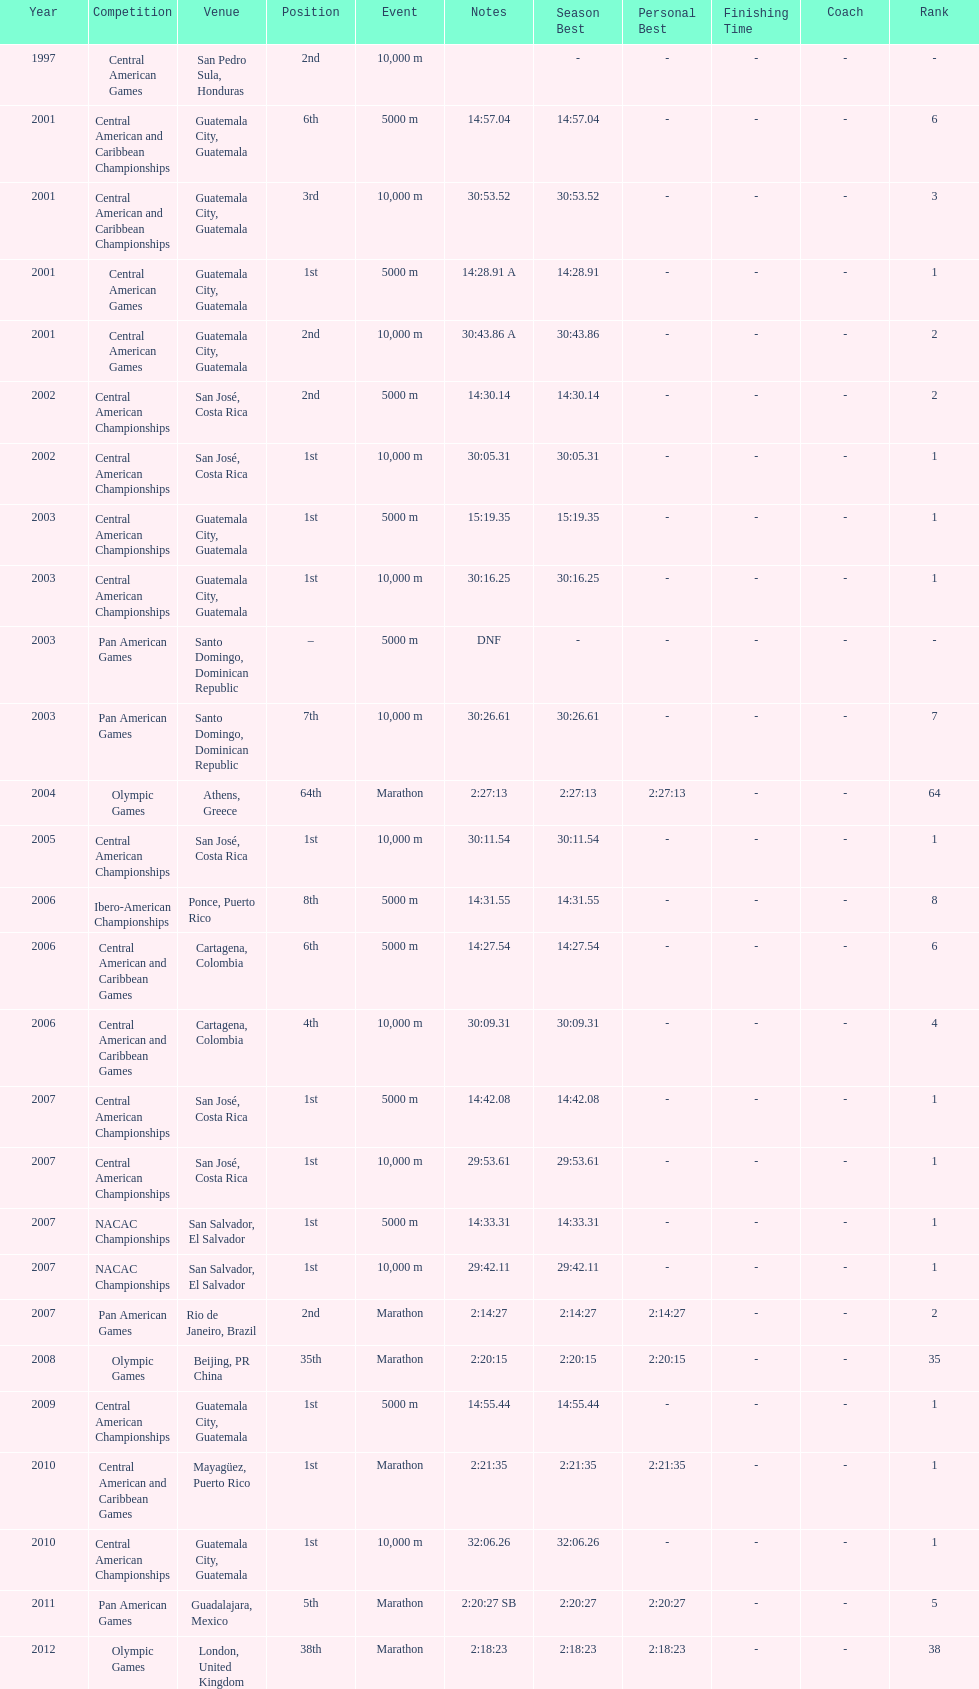Which event is listed more between the 10,000m and the 5000m? 10,000 m. 